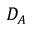<formula> <loc_0><loc_0><loc_500><loc_500>D _ { A }</formula> 